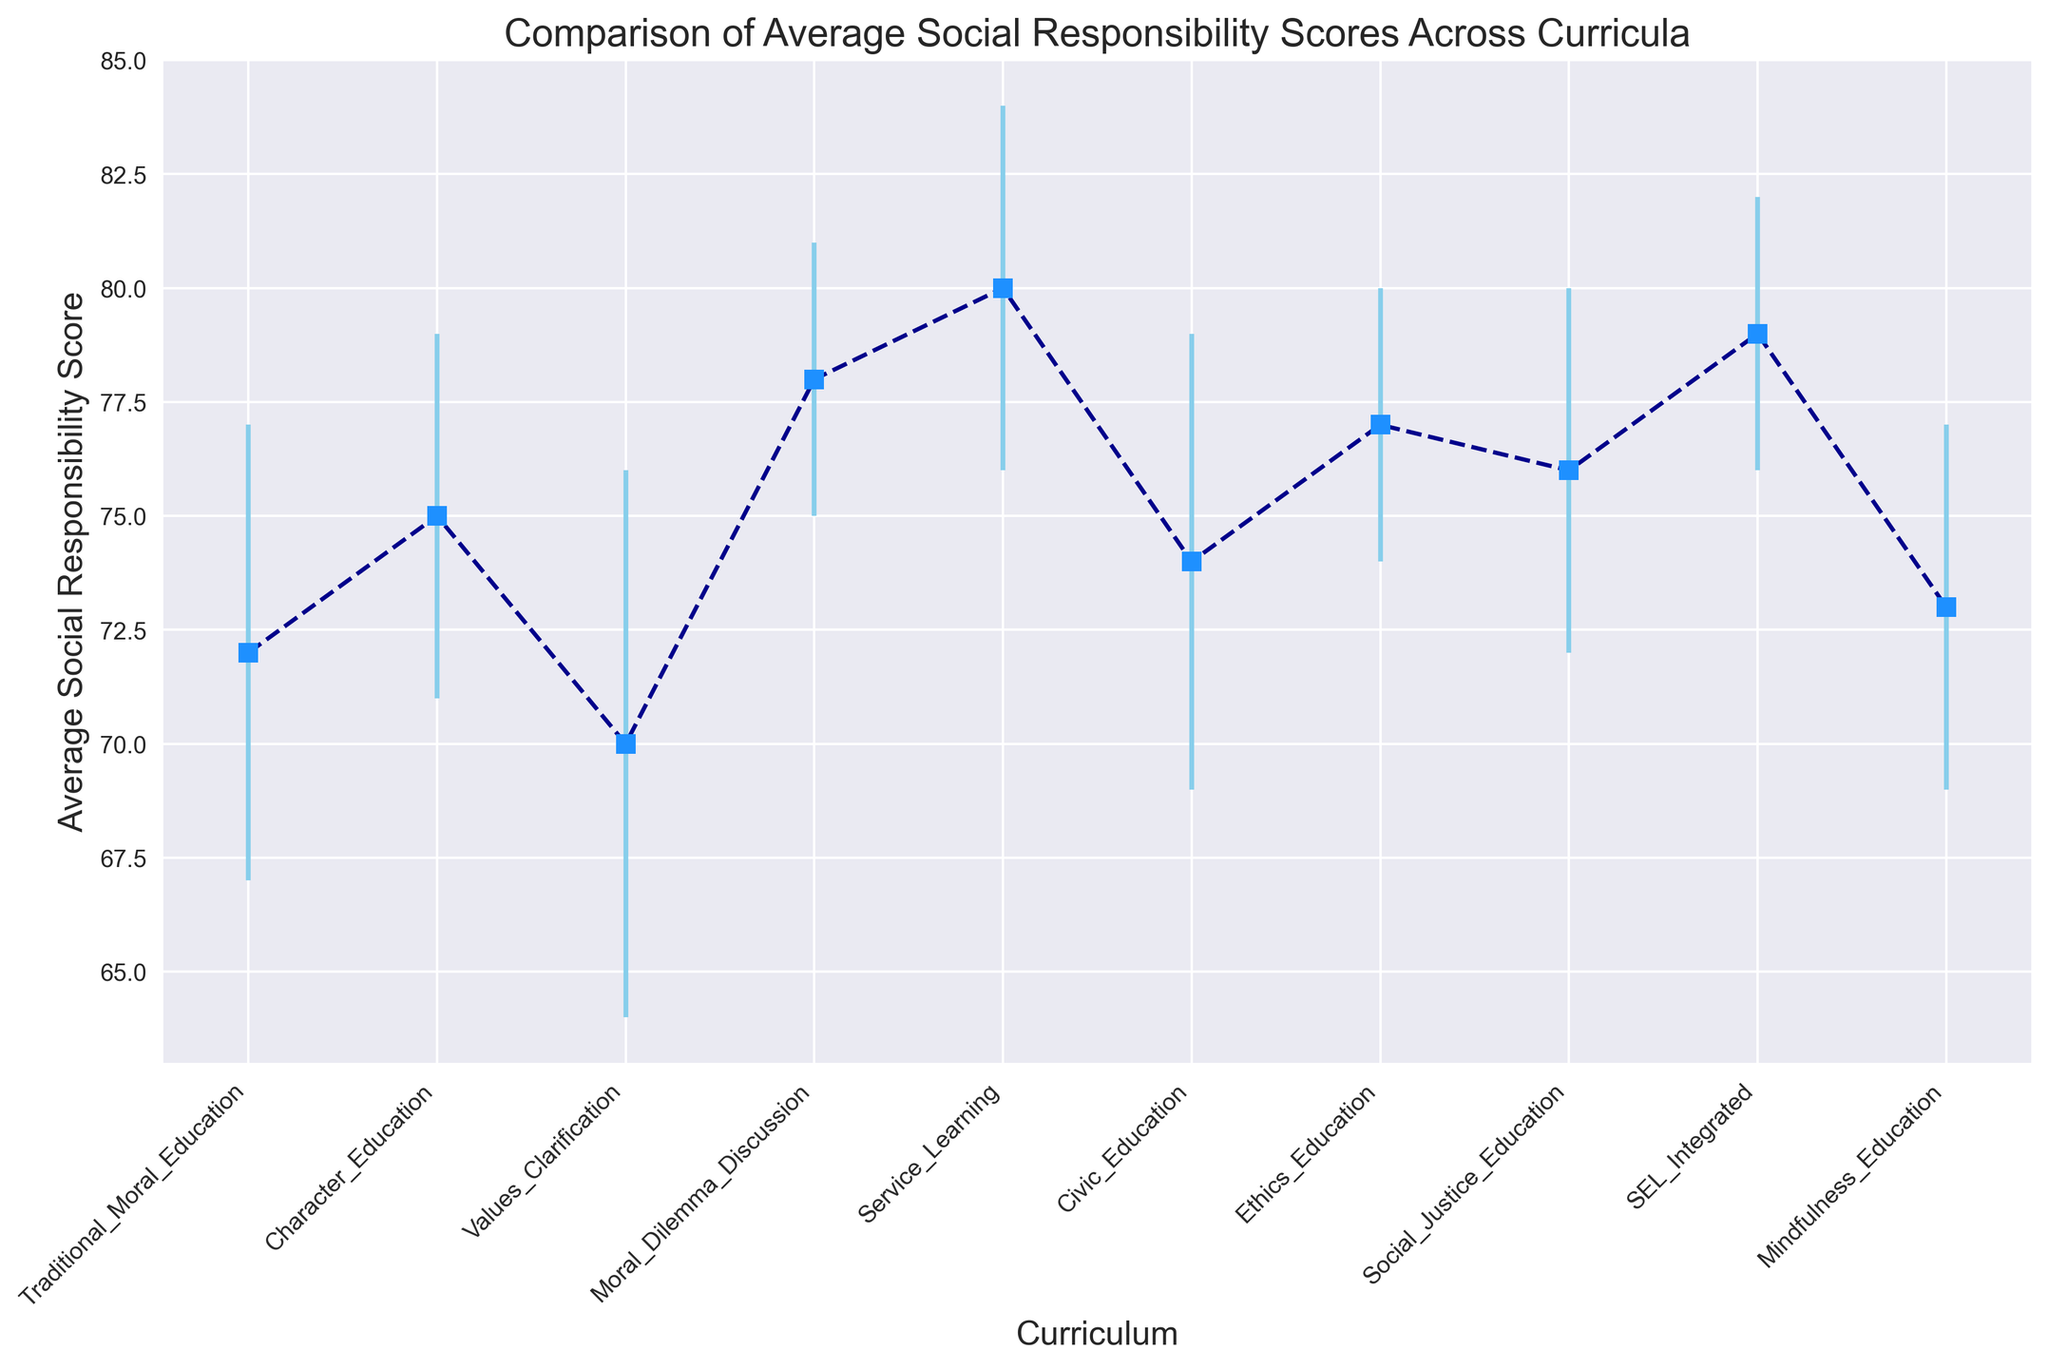Which curriculum shows the highest average social responsibility score? By checking the vertical positions of the markers, the highest average score can be found at the peak. The "Service Learning" curriculum has the highest score.
Answer: Service Learning Which curriculum has the lowest average social responsibility score? By identifying the marker at the lowest vertical position, the curriculum with the lowest average score is identifiable. "Values Clarification" shows the lowest score.
Answer: Values Clarification Which two curricula have the same error margin but different average scores? By examining the error bars, check for curricula with equal lengths. "Traditional Moral Education" and "Civic Education" both have error margins of 5. Their average scores differ (72 and 74).
Answer: Traditional Moral Education and Civic Education How much higher is the average score for "Service Learning" compared to "Traditional Moral Education"? Subtract the average score of "Traditional Moral Education" (72) from "Service Learning" (80). The difference is 80 - 72.
Answer: 8 Which curriculum has the smallest error margin, and what is its average score? Identify the shortest error bar. "Moral Dilemma Discussion" has the smallest error margin of 3 and its average score is 78.
Answer: Moral Dilemma Discussion, 78 What is the average of the average scores for "Character Education" and "Ethics Education"? Sum the average scores for "Character Education" (75) and "Ethics Education" (77), then divide by 2. (75 + 77) / 2 = 76.
Answer: 76 How many curricula have average scores greater than 75? Count the curricula with markers above the 75 mark on the y-axis. There are five: "Service Learning", "SEL Integrated", "Ethics Education", "Moral Dilemma Discussion", and "Social Justice Education".
Answer: 5 Compare the error margins of "Character Education" and "Mindfulness Education". Which one is larger and by how much? "Character Education" has an error margin of 4, while "Mindfulness Education" has an error margin of 4 as well. The margins are equal.
Answer: Equal, 0 What is the combined average score and error margin for "Service Learning" and "SEL Integrated"? Compute the average of (80 + 79) and the average of (4 + 3). (80 + 79) / 2 = 79.5; (4 + 3) / 2 = 3.5
Answer: 79.5, 3.5 